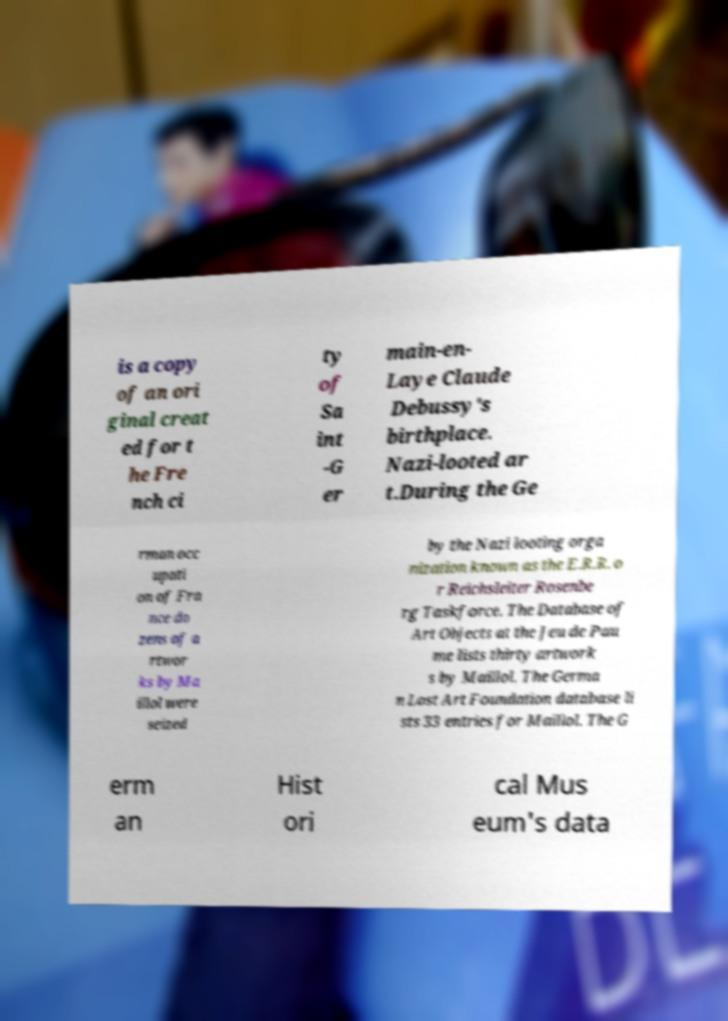Could you assist in decoding the text presented in this image and type it out clearly? is a copy of an ori ginal creat ed for t he Fre nch ci ty of Sa int -G er main-en- Laye Claude Debussy's birthplace. Nazi-looted ar t.During the Ge rman occ upati on of Fra nce do zens of a rtwor ks by Ma illol were seized by the Nazi looting orga nization known as the E.R.R. o r Reichsleiter Rosenbe rg Taskforce. The Database of Art Objects at the Jeu de Pau me lists thirty artwork s by Maillol. The Germa n Lost Art Foundation database li sts 33 entries for Maillol. The G erm an Hist ori cal Mus eum's data 